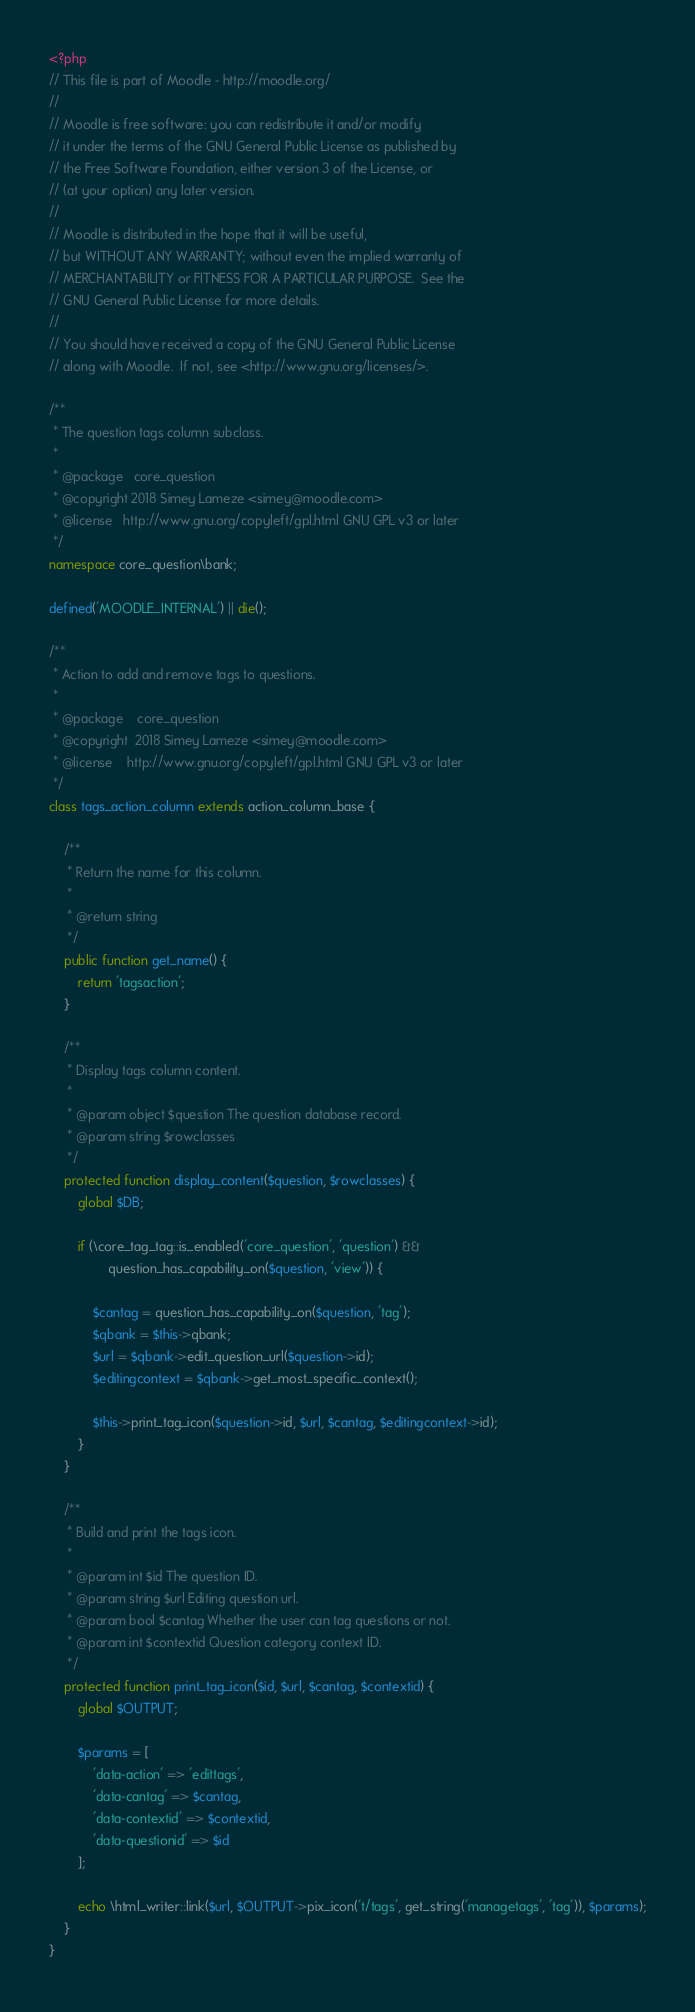Convert code to text. <code><loc_0><loc_0><loc_500><loc_500><_PHP_><?php
// This file is part of Moodle - http://moodle.org/
//
// Moodle is free software: you can redistribute it and/or modify
// it under the terms of the GNU General Public License as published by
// the Free Software Foundation, either version 3 of the License, or
// (at your option) any later version.
//
// Moodle is distributed in the hope that it will be useful,
// but WITHOUT ANY WARRANTY; without even the implied warranty of
// MERCHANTABILITY or FITNESS FOR A PARTICULAR PURPOSE.  See the
// GNU General Public License for more details.
//
// You should have received a copy of the GNU General Public License
// along with Moodle.  If not, see <http://www.gnu.org/licenses/>.

/**
 * The question tags column subclass.
 *
 * @package   core_question
 * @copyright 2018 Simey Lameze <simey@moodle.com>
 * @license   http://www.gnu.org/copyleft/gpl.html GNU GPL v3 or later
 */
namespace core_question\bank;

defined('MOODLE_INTERNAL') || die();

/**
 * Action to add and remove tags to questions.
 *
 * @package    core_question
 * @copyright  2018 Simey Lameze <simey@moodle.com>
 * @license    http://www.gnu.org/copyleft/gpl.html GNU GPL v3 or later
 */
class tags_action_column extends action_column_base {

    /**
     * Return the name for this column.
     *
     * @return string
     */
    public function get_name() {
        return 'tagsaction';
    }

    /**
     * Display tags column content.
     *
     * @param object $question The question database record.
     * @param string $rowclasses
     */
    protected function display_content($question, $rowclasses) {
        global $DB;

        if (\core_tag_tag::is_enabled('core_question', 'question') &&
                question_has_capability_on($question, 'view')) {

            $cantag = question_has_capability_on($question, 'tag');
            $qbank = $this->qbank;
            $url = $qbank->edit_question_url($question->id);
            $editingcontext = $qbank->get_most_specific_context();

            $this->print_tag_icon($question->id, $url, $cantag, $editingcontext->id);
        }
    }

    /**
     * Build and print the tags icon.
     *
     * @param int $id The question ID.
     * @param string $url Editing question url.
     * @param bool $cantag Whether the user can tag questions or not.
     * @param int $contextid Question category context ID.
     */
    protected function print_tag_icon($id, $url, $cantag, $contextid) {
        global $OUTPUT;

        $params = [
            'data-action' => 'edittags',
            'data-cantag' => $cantag,
            'data-contextid' => $contextid,
            'data-questionid' => $id
        ];

        echo \html_writer::link($url, $OUTPUT->pix_icon('t/tags', get_string('managetags', 'tag')), $params);
    }
}
</code> 